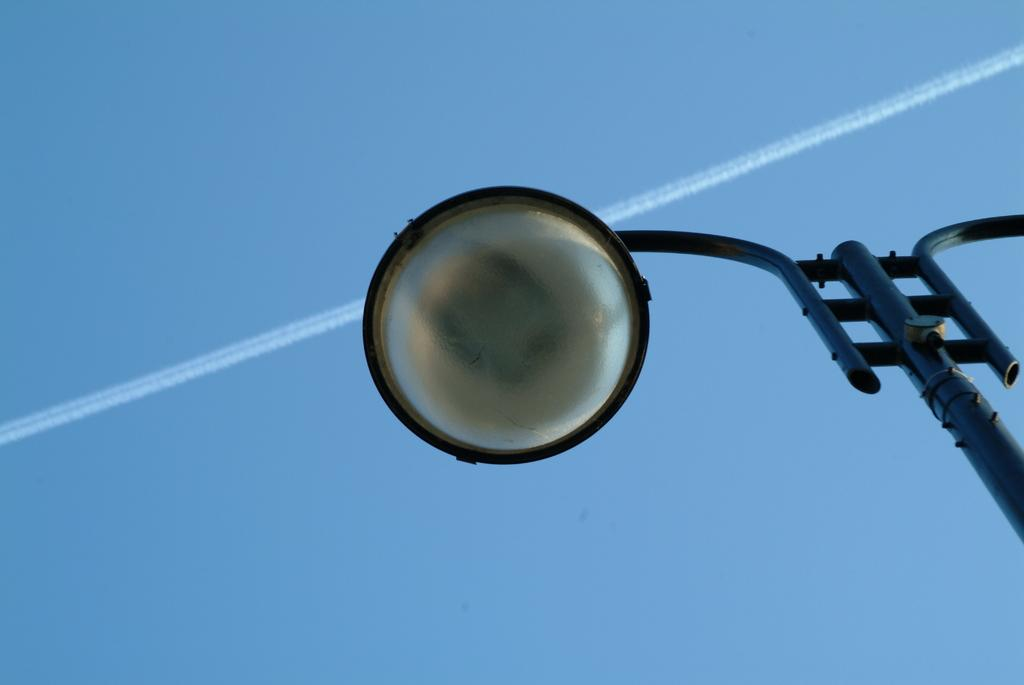What is the tall, vertical object in the image? There is a pole in the image. What is the purpose of the object on top of the pole? There is a street light in the image, which provides illumination. What can be seen at the top of the image? The sky is visible at the top of the image. What are the white, streaky lines in the sky? Contrails are present in the sky, which are formed by the exhaust of airplanes. How is the dirt being distributed in the image? There is no dirt present in the image. What type of health advice is being given in the image? There is no health advice or discussion in the image; it features a pole with a street light and a sky with contrails. 